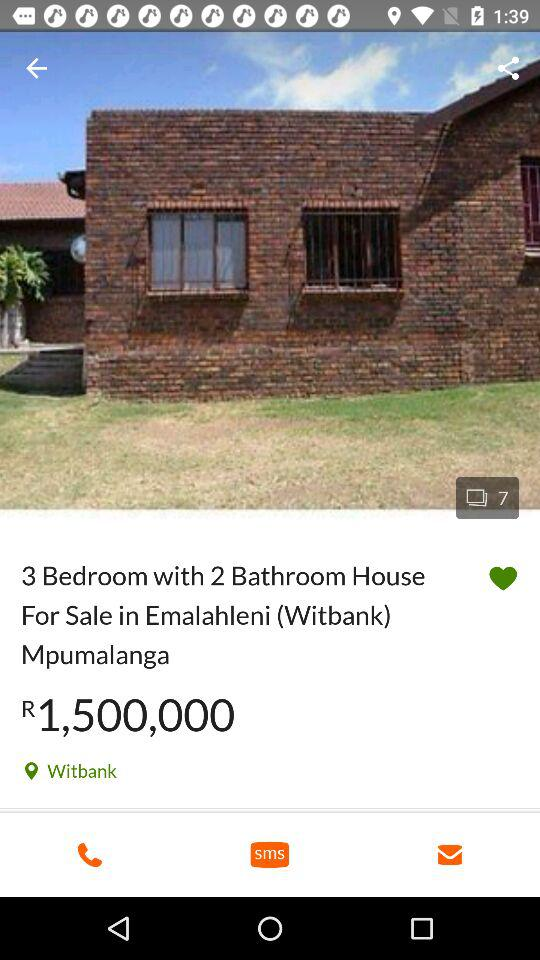How many photos in total are there? There are 7 photos in total. 